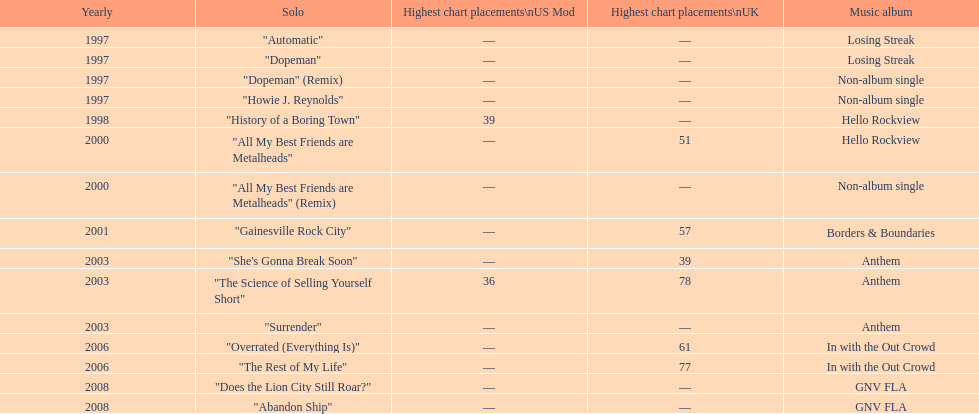Which single was released before "dopeman"? "Automatic". 